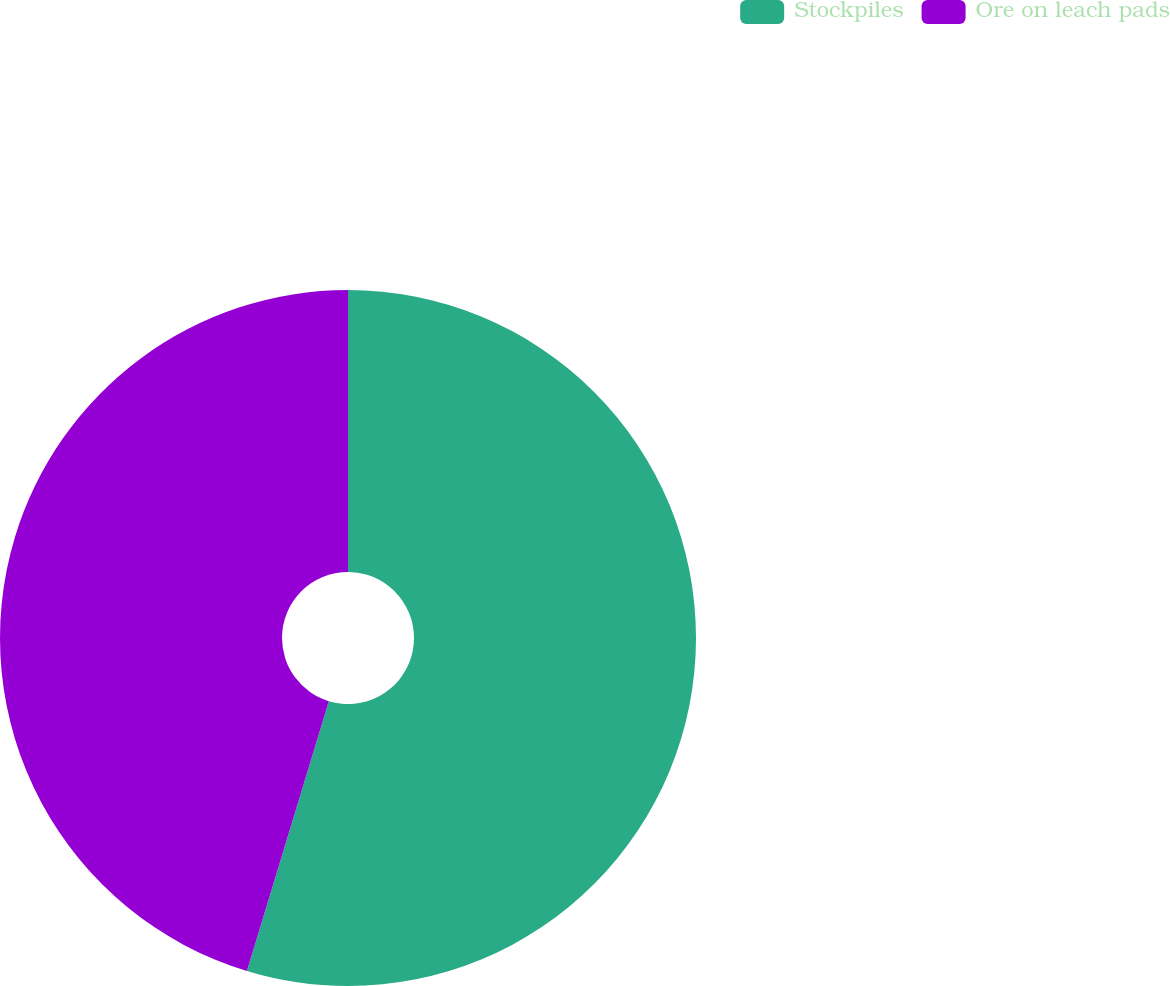Convert chart to OTSL. <chart><loc_0><loc_0><loc_500><loc_500><pie_chart><fcel>Stockpiles<fcel>Ore on leach pads<nl><fcel>54.69%<fcel>45.31%<nl></chart> 